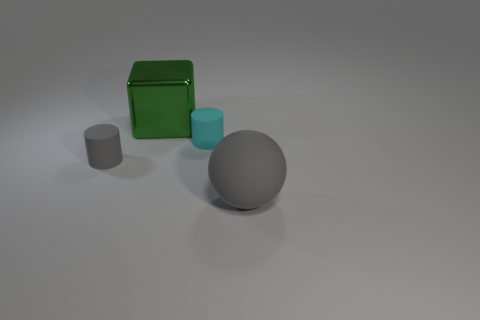What is the texture and lighting like in this scene? The scene has a soft, diffuse lighting that doesn't cast strong shadows. All objects have a smooth texture, and the surface upon which they rest appears to be a matte, slightly reflective material. 